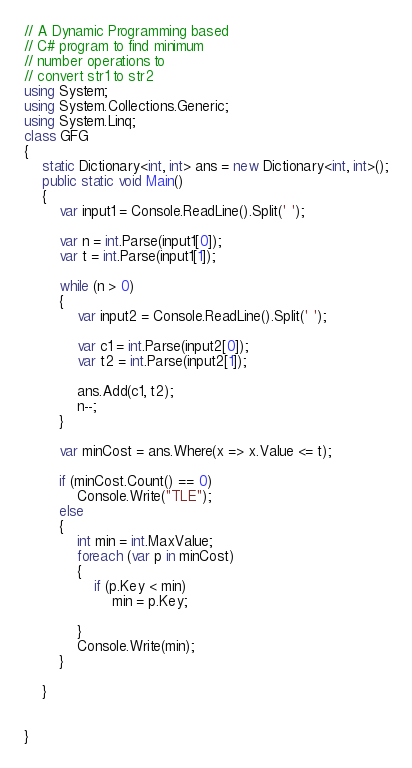<code> <loc_0><loc_0><loc_500><loc_500><_C#_>// A Dynamic Programming based 
// C# program to find minimum 
// number operations to 
// convert str1 to str2 
using System;
using System.Collections.Generic;
using System.Linq;
class GFG
{
    static Dictionary<int, int> ans = new Dictionary<int, int>();
    public static void Main()
    {
        var input1 = Console.ReadLine().Split(' ');

        var n = int.Parse(input1[0]);
        var t = int.Parse(input1[1]);

        while (n > 0)
        {
            var input2 = Console.ReadLine().Split(' ');

            var c1 = int.Parse(input2[0]);
            var t2 = int.Parse(input2[1]);

            ans.Add(c1, t2);
            n--;
        }

        var minCost = ans.Where(x => x.Value <= t);

        if (minCost.Count() == 0)
            Console.Write("TLE");
        else
        {
            int min = int.MaxValue;
            foreach (var p in minCost)
            {
                if (p.Key < min)
                    min = p.Key;

            }
            Console.Write(min);
        }

    }


}

</code> 